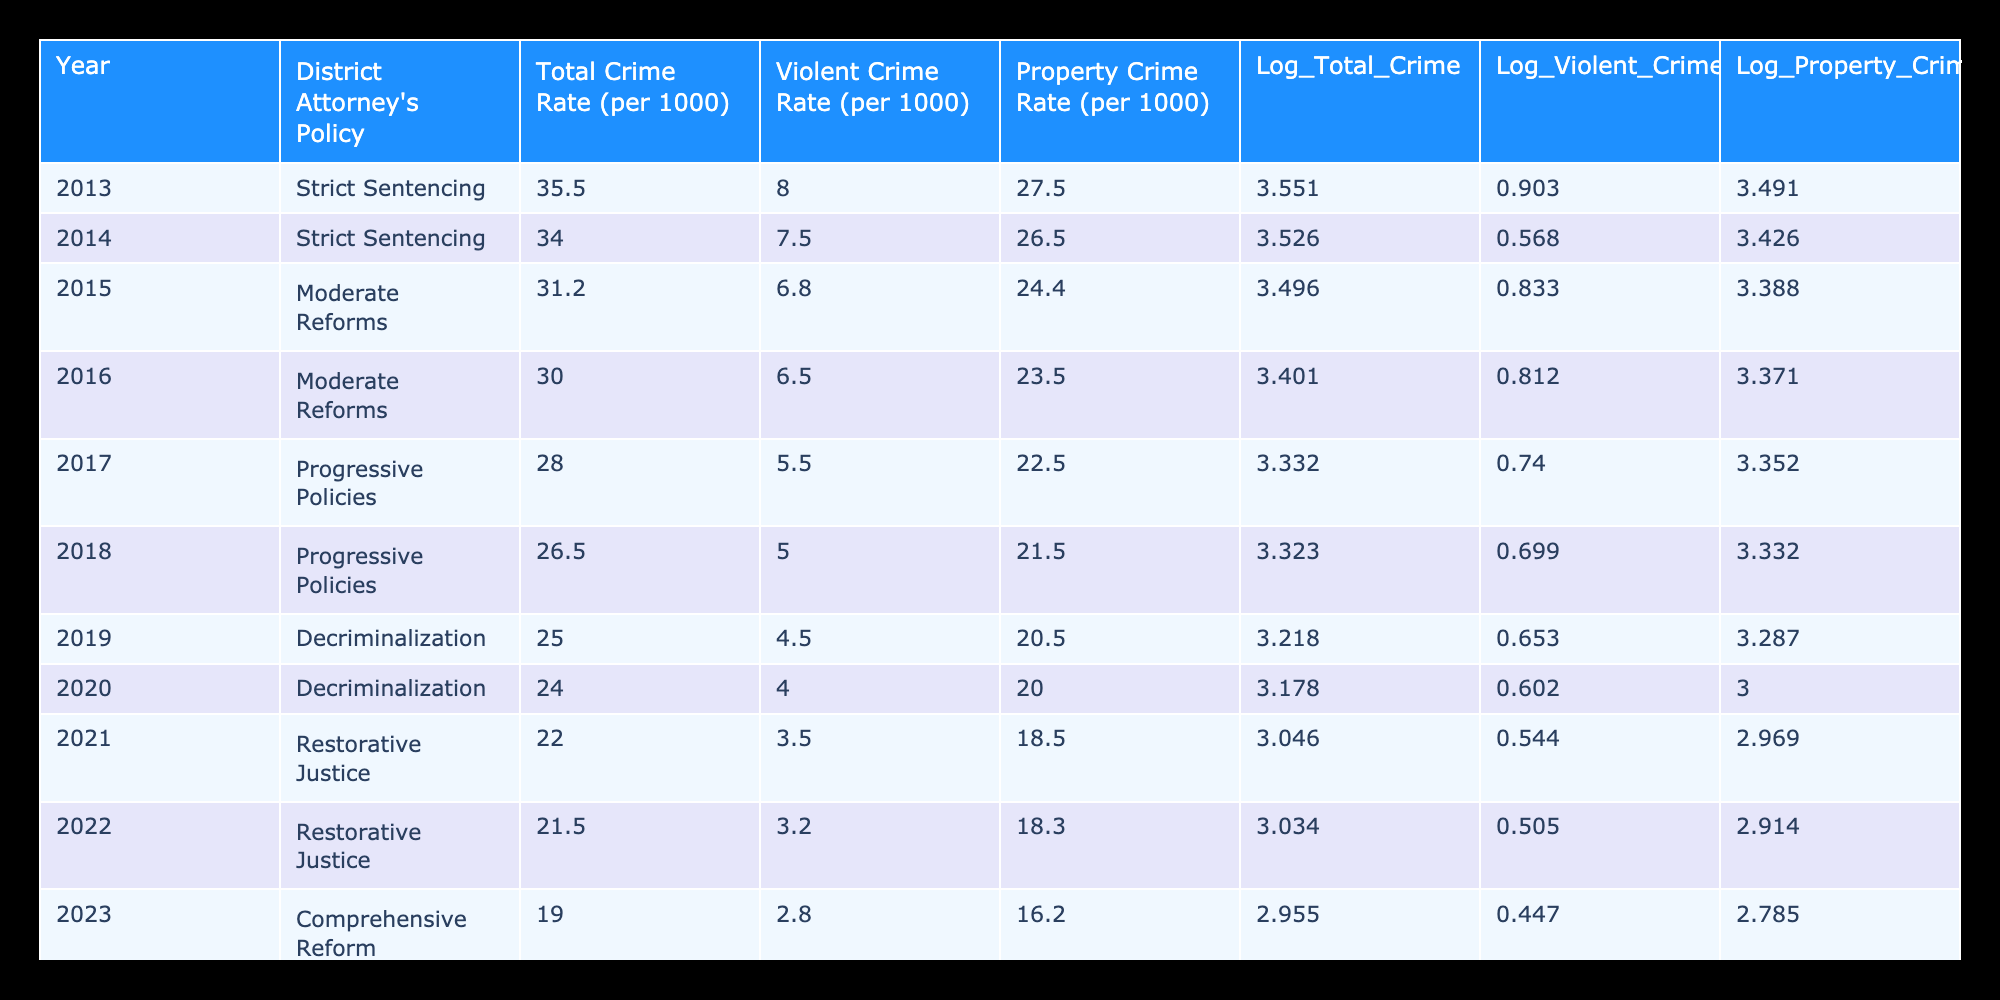What was the Total Crime Rate in 2019? The table shows a Total Crime Rate of 25.0 per 1000 for the year 2019.
Answer: 25.0 What is the Log Value of the Property Crime Rate for 2022? The table indicates a Log_Property_Crime of 2.914 for the year 2022.
Answer: 2.914 Which year had the lowest Violent Crime Rate? The year 2023 had the lowest Violent Crime Rate at 2.8 per 1000.
Answer: 2023 Was the Total Crime Rate higher in 2013 than in 2017? Comparing the Total Crime Rates, 2013 had 35.5 while 2017 had 28.0, thus 35.5 is greater than 28.0, confirming that it was higher.
Answer: Yes What is the difference in Total Crime Rate between 2013 and 2023? The Total Crime Rate in 2013 was 35.5 and in 2023 it was 19.0. The difference is 35.5 - 19.0 = 16.5.
Answer: 16.5 How many years had a Log_Total_Crime value below 3.1? The Log_Total_Crime values below 3.1 are for years 2023 (2.955), 2022 (3.034), 2021 (3.046), and 2020 (3.178). Counting these values gives 4 years.
Answer: 4 What was the average Violent Crime Rate from 2015 to 2019? The Violent Crime Rates from 2015 to 2019 are 6.8, 6.5, 5.5, and 4.5. Their sum is 6.8 + 6.5 + 5.5 + 4.5 = 23.3, and there are 5 values, so the average is 23.3 / 5 = 5.825.
Answer: 5.825 Did the transition from Strict Sentencing to Moderate Reforms correlate with a decrease in the Total Crime Rate? The Total Crime Rate decreased from 35.5 in 2013 to 31.2 in 2015 when moving from Strict Sentencing to Moderate Reforms. This indicates a decrease due to the change in policy.
Answer: Yes How does the Log_Violent_Crime of 2021 compare to that of 2015? The Log_Violent_Crime for 2021 is 0.544 while for 2015 it is 0.833. 0.544 is less than 0.833, indicating a decrease in Log_Violent_Crime.
Answer: Decrease 